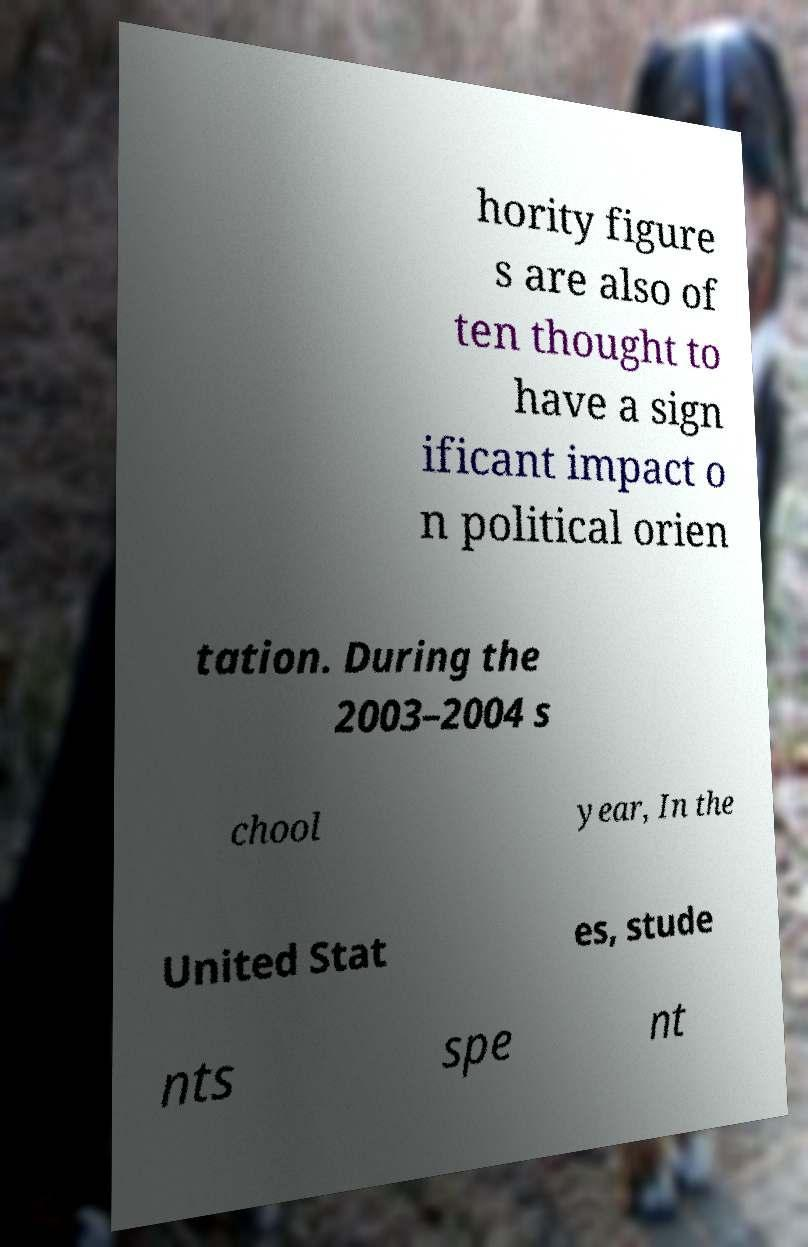Can you read and provide the text displayed in the image?This photo seems to have some interesting text. Can you extract and type it out for me? hority figure s are also of ten thought to have a sign ificant impact o n political orien tation. During the 2003–2004 s chool year, In the United Stat es, stude nts spe nt 